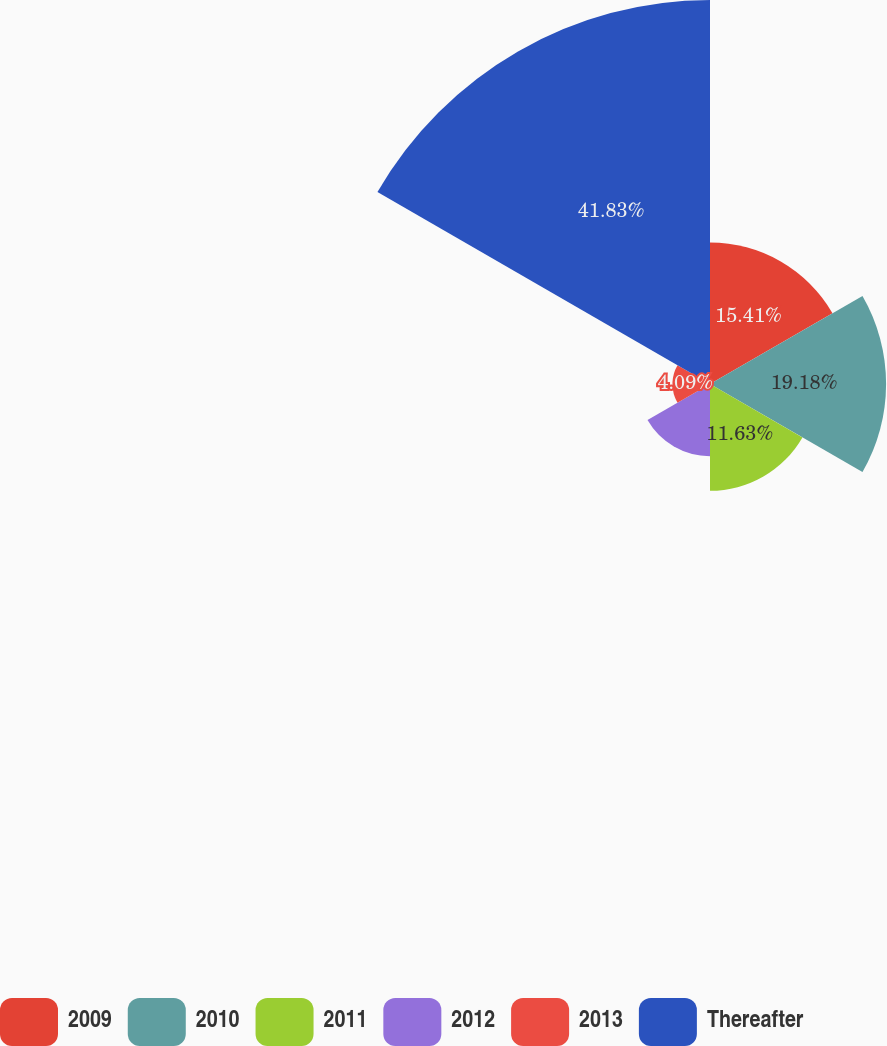Convert chart. <chart><loc_0><loc_0><loc_500><loc_500><pie_chart><fcel>2009<fcel>2010<fcel>2011<fcel>2012<fcel>2013<fcel>Thereafter<nl><fcel>15.41%<fcel>19.18%<fcel>11.63%<fcel>7.86%<fcel>4.09%<fcel>41.83%<nl></chart> 